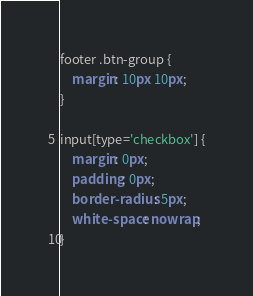Convert code to text. <code><loc_0><loc_0><loc_500><loc_500><_CSS_>footer .btn-group {
    margin: 10px 10px;
}

input[type='checkbox'] {
    margin: 0px;
    padding: 0px;
    border-radius: 5px;
    white-space: nowrap;
}
</code> 